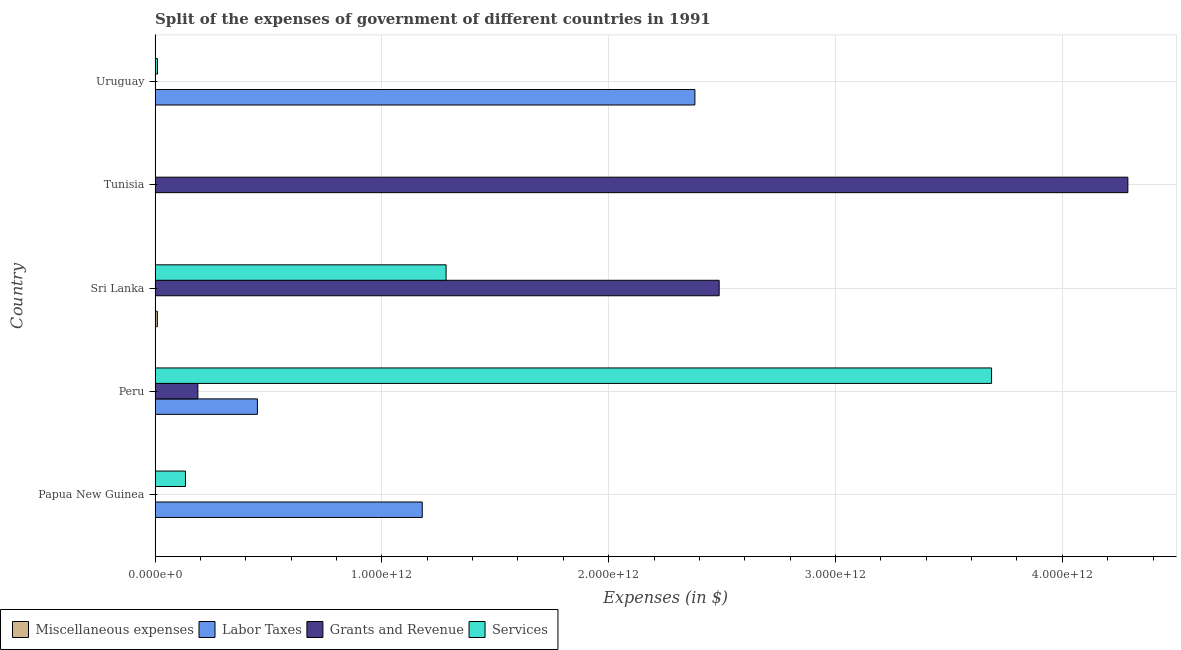Are the number of bars on each tick of the Y-axis equal?
Give a very brief answer. Yes. What is the label of the 3rd group of bars from the top?
Offer a terse response. Sri Lanka. In how many cases, is the number of bars for a given country not equal to the number of legend labels?
Your response must be concise. 0. What is the amount spent on grants and revenue in Uruguay?
Your answer should be very brief. 4.59e+08. Across all countries, what is the maximum amount spent on services?
Keep it short and to the point. 3.69e+12. In which country was the amount spent on grants and revenue maximum?
Keep it short and to the point. Tunisia. In which country was the amount spent on services minimum?
Keep it short and to the point. Tunisia. What is the total amount spent on miscellaneous expenses in the graph?
Provide a short and direct response. 1.04e+1. What is the difference between the amount spent on services in Papua New Guinea and that in Peru?
Keep it short and to the point. -3.55e+12. What is the difference between the amount spent on services in Sri Lanka and the amount spent on grants and revenue in Uruguay?
Give a very brief answer. 1.28e+12. What is the average amount spent on miscellaneous expenses per country?
Give a very brief answer. 2.07e+09. What is the difference between the amount spent on services and amount spent on labor taxes in Peru?
Give a very brief answer. 3.24e+12. In how many countries, is the amount spent on miscellaneous expenses greater than 2800000000000 $?
Ensure brevity in your answer.  0. What is the ratio of the amount spent on miscellaneous expenses in Peru to that in Sri Lanka?
Your answer should be very brief. 0. Is the difference between the amount spent on miscellaneous expenses in Sri Lanka and Tunisia greater than the difference between the amount spent on grants and revenue in Sri Lanka and Tunisia?
Your response must be concise. Yes. What is the difference between the highest and the second highest amount spent on miscellaneous expenses?
Make the answer very short. 9.67e+09. What is the difference between the highest and the lowest amount spent on labor taxes?
Offer a very short reply. 2.38e+12. In how many countries, is the amount spent on labor taxes greater than the average amount spent on labor taxes taken over all countries?
Offer a very short reply. 2. Is the sum of the amount spent on miscellaneous expenses in Papua New Guinea and Tunisia greater than the maximum amount spent on labor taxes across all countries?
Offer a very short reply. No. Is it the case that in every country, the sum of the amount spent on labor taxes and amount spent on grants and revenue is greater than the sum of amount spent on services and amount spent on miscellaneous expenses?
Provide a short and direct response. No. What does the 3rd bar from the top in Papua New Guinea represents?
Ensure brevity in your answer.  Labor Taxes. What does the 4th bar from the bottom in Sri Lanka represents?
Provide a succinct answer. Services. Is it the case that in every country, the sum of the amount spent on miscellaneous expenses and amount spent on labor taxes is greater than the amount spent on grants and revenue?
Provide a short and direct response. No. Are all the bars in the graph horizontal?
Provide a succinct answer. Yes. What is the difference between two consecutive major ticks on the X-axis?
Ensure brevity in your answer.  1.00e+12. How are the legend labels stacked?
Your answer should be very brief. Horizontal. What is the title of the graph?
Provide a succinct answer. Split of the expenses of government of different countries in 1991. Does "UNDP" appear as one of the legend labels in the graph?
Make the answer very short. No. What is the label or title of the X-axis?
Provide a short and direct response. Expenses (in $). What is the label or title of the Y-axis?
Make the answer very short. Country. What is the Expenses (in $) in Miscellaneous expenses in Papua New Guinea?
Your response must be concise. 5.01e+06. What is the Expenses (in $) in Labor Taxes in Papua New Guinea?
Keep it short and to the point. 1.18e+12. What is the Expenses (in $) of Grants and Revenue in Papua New Guinea?
Provide a short and direct response. 7.09e+08. What is the Expenses (in $) in Services in Papua New Guinea?
Offer a very short reply. 1.34e+11. What is the Expenses (in $) in Labor Taxes in Peru?
Offer a terse response. 4.51e+11. What is the Expenses (in $) in Grants and Revenue in Peru?
Give a very brief answer. 1.89e+11. What is the Expenses (in $) of Services in Peru?
Provide a succinct answer. 3.69e+12. What is the Expenses (in $) in Miscellaneous expenses in Sri Lanka?
Keep it short and to the point. 9.98e+09. What is the Expenses (in $) in Labor Taxes in Sri Lanka?
Provide a succinct answer. 7.18e+07. What is the Expenses (in $) in Grants and Revenue in Sri Lanka?
Provide a short and direct response. 2.49e+12. What is the Expenses (in $) of Services in Sri Lanka?
Ensure brevity in your answer.  1.28e+12. What is the Expenses (in $) of Miscellaneous expenses in Tunisia?
Your answer should be very brief. 3.12e+08. What is the Expenses (in $) in Labor Taxes in Tunisia?
Your response must be concise. 5.88e+08. What is the Expenses (in $) of Grants and Revenue in Tunisia?
Make the answer very short. 4.29e+12. What is the Expenses (in $) of Services in Tunisia?
Provide a short and direct response. 4.94e+07. What is the Expenses (in $) in Miscellaneous expenses in Uruguay?
Offer a very short reply. 5.50e+07. What is the Expenses (in $) in Labor Taxes in Uruguay?
Provide a succinct answer. 2.38e+12. What is the Expenses (in $) of Grants and Revenue in Uruguay?
Your answer should be very brief. 4.59e+08. What is the Expenses (in $) in Services in Uruguay?
Provide a succinct answer. 1.06e+1. Across all countries, what is the maximum Expenses (in $) of Miscellaneous expenses?
Offer a very short reply. 9.98e+09. Across all countries, what is the maximum Expenses (in $) in Labor Taxes?
Provide a short and direct response. 2.38e+12. Across all countries, what is the maximum Expenses (in $) in Grants and Revenue?
Give a very brief answer. 4.29e+12. Across all countries, what is the maximum Expenses (in $) in Services?
Ensure brevity in your answer.  3.69e+12. Across all countries, what is the minimum Expenses (in $) in Miscellaneous expenses?
Provide a short and direct response. 5.00e+06. Across all countries, what is the minimum Expenses (in $) of Labor Taxes?
Provide a short and direct response. 7.18e+07. Across all countries, what is the minimum Expenses (in $) in Grants and Revenue?
Make the answer very short. 4.59e+08. Across all countries, what is the minimum Expenses (in $) in Services?
Provide a succinct answer. 4.94e+07. What is the total Expenses (in $) in Miscellaneous expenses in the graph?
Your response must be concise. 1.04e+1. What is the total Expenses (in $) in Labor Taxes in the graph?
Offer a very short reply. 4.01e+12. What is the total Expenses (in $) of Grants and Revenue in the graph?
Make the answer very short. 6.97e+12. What is the total Expenses (in $) in Services in the graph?
Keep it short and to the point. 5.12e+12. What is the difference between the Expenses (in $) in Labor Taxes in Papua New Guinea and that in Peru?
Your answer should be very brief. 7.27e+11. What is the difference between the Expenses (in $) of Grants and Revenue in Papua New Guinea and that in Peru?
Your answer should be compact. -1.88e+11. What is the difference between the Expenses (in $) of Services in Papua New Guinea and that in Peru?
Provide a succinct answer. -3.55e+12. What is the difference between the Expenses (in $) of Miscellaneous expenses in Papua New Guinea and that in Sri Lanka?
Your answer should be very brief. -9.98e+09. What is the difference between the Expenses (in $) in Labor Taxes in Papua New Guinea and that in Sri Lanka?
Make the answer very short. 1.18e+12. What is the difference between the Expenses (in $) of Grants and Revenue in Papua New Guinea and that in Sri Lanka?
Give a very brief answer. -2.49e+12. What is the difference between the Expenses (in $) of Services in Papua New Guinea and that in Sri Lanka?
Your response must be concise. -1.15e+12. What is the difference between the Expenses (in $) in Miscellaneous expenses in Papua New Guinea and that in Tunisia?
Provide a succinct answer. -3.07e+08. What is the difference between the Expenses (in $) in Labor Taxes in Papua New Guinea and that in Tunisia?
Offer a very short reply. 1.18e+12. What is the difference between the Expenses (in $) in Grants and Revenue in Papua New Guinea and that in Tunisia?
Your answer should be compact. -4.29e+12. What is the difference between the Expenses (in $) of Services in Papua New Guinea and that in Tunisia?
Offer a terse response. 1.34e+11. What is the difference between the Expenses (in $) in Miscellaneous expenses in Papua New Guinea and that in Uruguay?
Ensure brevity in your answer.  -5.00e+07. What is the difference between the Expenses (in $) in Labor Taxes in Papua New Guinea and that in Uruguay?
Your answer should be compact. -1.20e+12. What is the difference between the Expenses (in $) of Grants and Revenue in Papua New Guinea and that in Uruguay?
Offer a terse response. 2.50e+08. What is the difference between the Expenses (in $) of Services in Papua New Guinea and that in Uruguay?
Your response must be concise. 1.23e+11. What is the difference between the Expenses (in $) of Miscellaneous expenses in Peru and that in Sri Lanka?
Provide a short and direct response. -9.98e+09. What is the difference between the Expenses (in $) in Labor Taxes in Peru and that in Sri Lanka?
Give a very brief answer. 4.51e+11. What is the difference between the Expenses (in $) of Grants and Revenue in Peru and that in Sri Lanka?
Your response must be concise. -2.30e+12. What is the difference between the Expenses (in $) in Services in Peru and that in Sri Lanka?
Make the answer very short. 2.40e+12. What is the difference between the Expenses (in $) of Miscellaneous expenses in Peru and that in Tunisia?
Provide a succinct answer. -3.07e+08. What is the difference between the Expenses (in $) in Labor Taxes in Peru and that in Tunisia?
Give a very brief answer. 4.51e+11. What is the difference between the Expenses (in $) of Grants and Revenue in Peru and that in Tunisia?
Your answer should be very brief. -4.10e+12. What is the difference between the Expenses (in $) of Services in Peru and that in Tunisia?
Offer a terse response. 3.69e+12. What is the difference between the Expenses (in $) of Miscellaneous expenses in Peru and that in Uruguay?
Offer a terse response. -5.00e+07. What is the difference between the Expenses (in $) of Labor Taxes in Peru and that in Uruguay?
Provide a short and direct response. -1.93e+12. What is the difference between the Expenses (in $) of Grants and Revenue in Peru and that in Uruguay?
Your answer should be compact. 1.88e+11. What is the difference between the Expenses (in $) in Services in Peru and that in Uruguay?
Ensure brevity in your answer.  3.68e+12. What is the difference between the Expenses (in $) in Miscellaneous expenses in Sri Lanka and that in Tunisia?
Keep it short and to the point. 9.67e+09. What is the difference between the Expenses (in $) of Labor Taxes in Sri Lanka and that in Tunisia?
Provide a succinct answer. -5.16e+08. What is the difference between the Expenses (in $) in Grants and Revenue in Sri Lanka and that in Tunisia?
Your response must be concise. -1.80e+12. What is the difference between the Expenses (in $) of Services in Sri Lanka and that in Tunisia?
Provide a short and direct response. 1.28e+12. What is the difference between the Expenses (in $) in Miscellaneous expenses in Sri Lanka and that in Uruguay?
Give a very brief answer. 9.93e+09. What is the difference between the Expenses (in $) in Labor Taxes in Sri Lanka and that in Uruguay?
Provide a short and direct response. -2.38e+12. What is the difference between the Expenses (in $) of Grants and Revenue in Sri Lanka and that in Uruguay?
Your answer should be very brief. 2.49e+12. What is the difference between the Expenses (in $) of Services in Sri Lanka and that in Uruguay?
Give a very brief answer. 1.27e+12. What is the difference between the Expenses (in $) in Miscellaneous expenses in Tunisia and that in Uruguay?
Your answer should be very brief. 2.57e+08. What is the difference between the Expenses (in $) of Labor Taxes in Tunisia and that in Uruguay?
Provide a succinct answer. -2.38e+12. What is the difference between the Expenses (in $) of Grants and Revenue in Tunisia and that in Uruguay?
Your answer should be compact. 4.29e+12. What is the difference between the Expenses (in $) in Services in Tunisia and that in Uruguay?
Provide a short and direct response. -1.05e+1. What is the difference between the Expenses (in $) of Miscellaneous expenses in Papua New Guinea and the Expenses (in $) of Labor Taxes in Peru?
Give a very brief answer. -4.51e+11. What is the difference between the Expenses (in $) in Miscellaneous expenses in Papua New Guinea and the Expenses (in $) in Grants and Revenue in Peru?
Your answer should be very brief. -1.89e+11. What is the difference between the Expenses (in $) in Miscellaneous expenses in Papua New Guinea and the Expenses (in $) in Services in Peru?
Provide a short and direct response. -3.69e+12. What is the difference between the Expenses (in $) of Labor Taxes in Papua New Guinea and the Expenses (in $) of Grants and Revenue in Peru?
Provide a succinct answer. 9.89e+11. What is the difference between the Expenses (in $) in Labor Taxes in Papua New Guinea and the Expenses (in $) in Services in Peru?
Offer a very short reply. -2.51e+12. What is the difference between the Expenses (in $) in Grants and Revenue in Papua New Guinea and the Expenses (in $) in Services in Peru?
Offer a very short reply. -3.69e+12. What is the difference between the Expenses (in $) in Miscellaneous expenses in Papua New Guinea and the Expenses (in $) in Labor Taxes in Sri Lanka?
Give a very brief answer. -6.68e+07. What is the difference between the Expenses (in $) of Miscellaneous expenses in Papua New Guinea and the Expenses (in $) of Grants and Revenue in Sri Lanka?
Offer a very short reply. -2.49e+12. What is the difference between the Expenses (in $) in Miscellaneous expenses in Papua New Guinea and the Expenses (in $) in Services in Sri Lanka?
Your answer should be compact. -1.28e+12. What is the difference between the Expenses (in $) of Labor Taxes in Papua New Guinea and the Expenses (in $) of Grants and Revenue in Sri Lanka?
Make the answer very short. -1.31e+12. What is the difference between the Expenses (in $) of Labor Taxes in Papua New Guinea and the Expenses (in $) of Services in Sri Lanka?
Make the answer very short. -1.05e+11. What is the difference between the Expenses (in $) of Grants and Revenue in Papua New Guinea and the Expenses (in $) of Services in Sri Lanka?
Your answer should be very brief. -1.28e+12. What is the difference between the Expenses (in $) of Miscellaneous expenses in Papua New Guinea and the Expenses (in $) of Labor Taxes in Tunisia?
Offer a terse response. -5.83e+08. What is the difference between the Expenses (in $) of Miscellaneous expenses in Papua New Guinea and the Expenses (in $) of Grants and Revenue in Tunisia?
Keep it short and to the point. -4.29e+12. What is the difference between the Expenses (in $) in Miscellaneous expenses in Papua New Guinea and the Expenses (in $) in Services in Tunisia?
Your response must be concise. -4.44e+07. What is the difference between the Expenses (in $) of Labor Taxes in Papua New Guinea and the Expenses (in $) of Grants and Revenue in Tunisia?
Your answer should be very brief. -3.11e+12. What is the difference between the Expenses (in $) in Labor Taxes in Papua New Guinea and the Expenses (in $) in Services in Tunisia?
Ensure brevity in your answer.  1.18e+12. What is the difference between the Expenses (in $) in Grants and Revenue in Papua New Guinea and the Expenses (in $) in Services in Tunisia?
Your answer should be very brief. 6.60e+08. What is the difference between the Expenses (in $) of Miscellaneous expenses in Papua New Guinea and the Expenses (in $) of Labor Taxes in Uruguay?
Offer a terse response. -2.38e+12. What is the difference between the Expenses (in $) of Miscellaneous expenses in Papua New Guinea and the Expenses (in $) of Grants and Revenue in Uruguay?
Your answer should be very brief. -4.54e+08. What is the difference between the Expenses (in $) of Miscellaneous expenses in Papua New Guinea and the Expenses (in $) of Services in Uruguay?
Keep it short and to the point. -1.06e+1. What is the difference between the Expenses (in $) of Labor Taxes in Papua New Guinea and the Expenses (in $) of Grants and Revenue in Uruguay?
Give a very brief answer. 1.18e+12. What is the difference between the Expenses (in $) in Labor Taxes in Papua New Guinea and the Expenses (in $) in Services in Uruguay?
Your answer should be very brief. 1.17e+12. What is the difference between the Expenses (in $) of Grants and Revenue in Papua New Guinea and the Expenses (in $) of Services in Uruguay?
Ensure brevity in your answer.  -9.85e+09. What is the difference between the Expenses (in $) in Miscellaneous expenses in Peru and the Expenses (in $) in Labor Taxes in Sri Lanka?
Offer a terse response. -6.68e+07. What is the difference between the Expenses (in $) in Miscellaneous expenses in Peru and the Expenses (in $) in Grants and Revenue in Sri Lanka?
Keep it short and to the point. -2.49e+12. What is the difference between the Expenses (in $) of Miscellaneous expenses in Peru and the Expenses (in $) of Services in Sri Lanka?
Give a very brief answer. -1.28e+12. What is the difference between the Expenses (in $) in Labor Taxes in Peru and the Expenses (in $) in Grants and Revenue in Sri Lanka?
Make the answer very short. -2.04e+12. What is the difference between the Expenses (in $) of Labor Taxes in Peru and the Expenses (in $) of Services in Sri Lanka?
Provide a short and direct response. -8.32e+11. What is the difference between the Expenses (in $) in Grants and Revenue in Peru and the Expenses (in $) in Services in Sri Lanka?
Provide a short and direct response. -1.09e+12. What is the difference between the Expenses (in $) in Miscellaneous expenses in Peru and the Expenses (in $) in Labor Taxes in Tunisia?
Offer a terse response. -5.83e+08. What is the difference between the Expenses (in $) in Miscellaneous expenses in Peru and the Expenses (in $) in Grants and Revenue in Tunisia?
Provide a short and direct response. -4.29e+12. What is the difference between the Expenses (in $) in Miscellaneous expenses in Peru and the Expenses (in $) in Services in Tunisia?
Give a very brief answer. -4.44e+07. What is the difference between the Expenses (in $) in Labor Taxes in Peru and the Expenses (in $) in Grants and Revenue in Tunisia?
Your answer should be compact. -3.84e+12. What is the difference between the Expenses (in $) of Labor Taxes in Peru and the Expenses (in $) of Services in Tunisia?
Your answer should be compact. 4.51e+11. What is the difference between the Expenses (in $) of Grants and Revenue in Peru and the Expenses (in $) of Services in Tunisia?
Offer a very short reply. 1.89e+11. What is the difference between the Expenses (in $) of Miscellaneous expenses in Peru and the Expenses (in $) of Labor Taxes in Uruguay?
Give a very brief answer. -2.38e+12. What is the difference between the Expenses (in $) of Miscellaneous expenses in Peru and the Expenses (in $) of Grants and Revenue in Uruguay?
Make the answer very short. -4.54e+08. What is the difference between the Expenses (in $) in Miscellaneous expenses in Peru and the Expenses (in $) in Services in Uruguay?
Make the answer very short. -1.06e+1. What is the difference between the Expenses (in $) of Labor Taxes in Peru and the Expenses (in $) of Grants and Revenue in Uruguay?
Make the answer very short. 4.51e+11. What is the difference between the Expenses (in $) of Labor Taxes in Peru and the Expenses (in $) of Services in Uruguay?
Ensure brevity in your answer.  4.41e+11. What is the difference between the Expenses (in $) in Grants and Revenue in Peru and the Expenses (in $) in Services in Uruguay?
Your answer should be compact. 1.78e+11. What is the difference between the Expenses (in $) of Miscellaneous expenses in Sri Lanka and the Expenses (in $) of Labor Taxes in Tunisia?
Give a very brief answer. 9.39e+09. What is the difference between the Expenses (in $) of Miscellaneous expenses in Sri Lanka and the Expenses (in $) of Grants and Revenue in Tunisia?
Your answer should be compact. -4.28e+12. What is the difference between the Expenses (in $) of Miscellaneous expenses in Sri Lanka and the Expenses (in $) of Services in Tunisia?
Give a very brief answer. 9.93e+09. What is the difference between the Expenses (in $) of Labor Taxes in Sri Lanka and the Expenses (in $) of Grants and Revenue in Tunisia?
Your answer should be compact. -4.29e+12. What is the difference between the Expenses (in $) of Labor Taxes in Sri Lanka and the Expenses (in $) of Services in Tunisia?
Make the answer very short. 2.24e+07. What is the difference between the Expenses (in $) in Grants and Revenue in Sri Lanka and the Expenses (in $) in Services in Tunisia?
Your answer should be compact. 2.49e+12. What is the difference between the Expenses (in $) of Miscellaneous expenses in Sri Lanka and the Expenses (in $) of Labor Taxes in Uruguay?
Offer a terse response. -2.37e+12. What is the difference between the Expenses (in $) in Miscellaneous expenses in Sri Lanka and the Expenses (in $) in Grants and Revenue in Uruguay?
Your answer should be compact. 9.52e+09. What is the difference between the Expenses (in $) in Miscellaneous expenses in Sri Lanka and the Expenses (in $) in Services in Uruguay?
Keep it short and to the point. -5.76e+08. What is the difference between the Expenses (in $) of Labor Taxes in Sri Lanka and the Expenses (in $) of Grants and Revenue in Uruguay?
Provide a succinct answer. -3.88e+08. What is the difference between the Expenses (in $) in Labor Taxes in Sri Lanka and the Expenses (in $) in Services in Uruguay?
Provide a succinct answer. -1.05e+1. What is the difference between the Expenses (in $) in Grants and Revenue in Sri Lanka and the Expenses (in $) in Services in Uruguay?
Give a very brief answer. 2.48e+12. What is the difference between the Expenses (in $) in Miscellaneous expenses in Tunisia and the Expenses (in $) in Labor Taxes in Uruguay?
Offer a very short reply. -2.38e+12. What is the difference between the Expenses (in $) of Miscellaneous expenses in Tunisia and the Expenses (in $) of Grants and Revenue in Uruguay?
Keep it short and to the point. -1.48e+08. What is the difference between the Expenses (in $) in Miscellaneous expenses in Tunisia and the Expenses (in $) in Services in Uruguay?
Your answer should be very brief. -1.02e+1. What is the difference between the Expenses (in $) in Labor Taxes in Tunisia and the Expenses (in $) in Grants and Revenue in Uruguay?
Make the answer very short. 1.29e+08. What is the difference between the Expenses (in $) of Labor Taxes in Tunisia and the Expenses (in $) of Services in Uruguay?
Offer a very short reply. -9.97e+09. What is the difference between the Expenses (in $) of Grants and Revenue in Tunisia and the Expenses (in $) of Services in Uruguay?
Ensure brevity in your answer.  4.28e+12. What is the average Expenses (in $) in Miscellaneous expenses per country?
Keep it short and to the point. 2.07e+09. What is the average Expenses (in $) of Labor Taxes per country?
Your response must be concise. 8.02e+11. What is the average Expenses (in $) in Grants and Revenue per country?
Give a very brief answer. 1.39e+12. What is the average Expenses (in $) in Services per country?
Provide a succinct answer. 1.02e+12. What is the difference between the Expenses (in $) in Miscellaneous expenses and Expenses (in $) in Labor Taxes in Papua New Guinea?
Your answer should be very brief. -1.18e+12. What is the difference between the Expenses (in $) in Miscellaneous expenses and Expenses (in $) in Grants and Revenue in Papua New Guinea?
Offer a very short reply. -7.04e+08. What is the difference between the Expenses (in $) in Miscellaneous expenses and Expenses (in $) in Services in Papua New Guinea?
Give a very brief answer. -1.34e+11. What is the difference between the Expenses (in $) of Labor Taxes and Expenses (in $) of Grants and Revenue in Papua New Guinea?
Offer a very short reply. 1.18e+12. What is the difference between the Expenses (in $) in Labor Taxes and Expenses (in $) in Services in Papua New Guinea?
Your response must be concise. 1.04e+12. What is the difference between the Expenses (in $) of Grants and Revenue and Expenses (in $) of Services in Papua New Guinea?
Your response must be concise. -1.33e+11. What is the difference between the Expenses (in $) in Miscellaneous expenses and Expenses (in $) in Labor Taxes in Peru?
Provide a short and direct response. -4.51e+11. What is the difference between the Expenses (in $) in Miscellaneous expenses and Expenses (in $) in Grants and Revenue in Peru?
Keep it short and to the point. -1.89e+11. What is the difference between the Expenses (in $) of Miscellaneous expenses and Expenses (in $) of Services in Peru?
Provide a succinct answer. -3.69e+12. What is the difference between the Expenses (in $) of Labor Taxes and Expenses (in $) of Grants and Revenue in Peru?
Offer a very short reply. 2.63e+11. What is the difference between the Expenses (in $) of Labor Taxes and Expenses (in $) of Services in Peru?
Provide a succinct answer. -3.24e+12. What is the difference between the Expenses (in $) in Grants and Revenue and Expenses (in $) in Services in Peru?
Your answer should be very brief. -3.50e+12. What is the difference between the Expenses (in $) in Miscellaneous expenses and Expenses (in $) in Labor Taxes in Sri Lanka?
Provide a succinct answer. 9.91e+09. What is the difference between the Expenses (in $) of Miscellaneous expenses and Expenses (in $) of Grants and Revenue in Sri Lanka?
Offer a very short reply. -2.48e+12. What is the difference between the Expenses (in $) of Miscellaneous expenses and Expenses (in $) of Services in Sri Lanka?
Your answer should be compact. -1.27e+12. What is the difference between the Expenses (in $) of Labor Taxes and Expenses (in $) of Grants and Revenue in Sri Lanka?
Your response must be concise. -2.49e+12. What is the difference between the Expenses (in $) in Labor Taxes and Expenses (in $) in Services in Sri Lanka?
Keep it short and to the point. -1.28e+12. What is the difference between the Expenses (in $) in Grants and Revenue and Expenses (in $) in Services in Sri Lanka?
Your response must be concise. 1.20e+12. What is the difference between the Expenses (in $) of Miscellaneous expenses and Expenses (in $) of Labor Taxes in Tunisia?
Offer a very short reply. -2.76e+08. What is the difference between the Expenses (in $) of Miscellaneous expenses and Expenses (in $) of Grants and Revenue in Tunisia?
Offer a terse response. -4.29e+12. What is the difference between the Expenses (in $) in Miscellaneous expenses and Expenses (in $) in Services in Tunisia?
Provide a succinct answer. 2.62e+08. What is the difference between the Expenses (in $) in Labor Taxes and Expenses (in $) in Grants and Revenue in Tunisia?
Make the answer very short. -4.29e+12. What is the difference between the Expenses (in $) in Labor Taxes and Expenses (in $) in Services in Tunisia?
Make the answer very short. 5.39e+08. What is the difference between the Expenses (in $) of Grants and Revenue and Expenses (in $) of Services in Tunisia?
Your response must be concise. 4.29e+12. What is the difference between the Expenses (in $) in Miscellaneous expenses and Expenses (in $) in Labor Taxes in Uruguay?
Your answer should be compact. -2.38e+12. What is the difference between the Expenses (in $) of Miscellaneous expenses and Expenses (in $) of Grants and Revenue in Uruguay?
Your response must be concise. -4.04e+08. What is the difference between the Expenses (in $) of Miscellaneous expenses and Expenses (in $) of Services in Uruguay?
Provide a short and direct response. -1.05e+1. What is the difference between the Expenses (in $) in Labor Taxes and Expenses (in $) in Grants and Revenue in Uruguay?
Give a very brief answer. 2.38e+12. What is the difference between the Expenses (in $) of Labor Taxes and Expenses (in $) of Services in Uruguay?
Provide a succinct answer. 2.37e+12. What is the difference between the Expenses (in $) in Grants and Revenue and Expenses (in $) in Services in Uruguay?
Your answer should be compact. -1.01e+1. What is the ratio of the Expenses (in $) in Miscellaneous expenses in Papua New Guinea to that in Peru?
Offer a terse response. 1. What is the ratio of the Expenses (in $) of Labor Taxes in Papua New Guinea to that in Peru?
Make the answer very short. 2.61. What is the ratio of the Expenses (in $) of Grants and Revenue in Papua New Guinea to that in Peru?
Make the answer very short. 0. What is the ratio of the Expenses (in $) in Services in Papua New Guinea to that in Peru?
Provide a short and direct response. 0.04. What is the ratio of the Expenses (in $) in Labor Taxes in Papua New Guinea to that in Sri Lanka?
Provide a succinct answer. 1.64e+04. What is the ratio of the Expenses (in $) in Services in Papua New Guinea to that in Sri Lanka?
Your answer should be compact. 0.1. What is the ratio of the Expenses (in $) of Miscellaneous expenses in Papua New Guinea to that in Tunisia?
Provide a short and direct response. 0.02. What is the ratio of the Expenses (in $) in Labor Taxes in Papua New Guinea to that in Tunisia?
Make the answer very short. 2003.4. What is the ratio of the Expenses (in $) of Services in Papua New Guinea to that in Tunisia?
Offer a terse response. 2711.39. What is the ratio of the Expenses (in $) in Miscellaneous expenses in Papua New Guinea to that in Uruguay?
Keep it short and to the point. 0.09. What is the ratio of the Expenses (in $) in Labor Taxes in Papua New Guinea to that in Uruguay?
Make the answer very short. 0.49. What is the ratio of the Expenses (in $) of Grants and Revenue in Papua New Guinea to that in Uruguay?
Your answer should be very brief. 1.54. What is the ratio of the Expenses (in $) in Services in Papua New Guinea to that in Uruguay?
Offer a very short reply. 12.69. What is the ratio of the Expenses (in $) of Labor Taxes in Peru to that in Sri Lanka?
Offer a terse response. 6279.75. What is the ratio of the Expenses (in $) of Grants and Revenue in Peru to that in Sri Lanka?
Make the answer very short. 0.08. What is the ratio of the Expenses (in $) of Services in Peru to that in Sri Lanka?
Provide a succinct answer. 2.87. What is the ratio of the Expenses (in $) of Miscellaneous expenses in Peru to that in Tunisia?
Your answer should be compact. 0.02. What is the ratio of the Expenses (in $) of Labor Taxes in Peru to that in Tunisia?
Ensure brevity in your answer.  767.35. What is the ratio of the Expenses (in $) of Grants and Revenue in Peru to that in Tunisia?
Give a very brief answer. 0.04. What is the ratio of the Expenses (in $) of Services in Peru to that in Tunisia?
Provide a succinct answer. 7.46e+04. What is the ratio of the Expenses (in $) of Miscellaneous expenses in Peru to that in Uruguay?
Make the answer very short. 0.09. What is the ratio of the Expenses (in $) in Labor Taxes in Peru to that in Uruguay?
Offer a very short reply. 0.19. What is the ratio of the Expenses (in $) of Grants and Revenue in Peru to that in Uruguay?
Keep it short and to the point. 410.66. What is the ratio of the Expenses (in $) in Services in Peru to that in Uruguay?
Offer a very short reply. 349.31. What is the ratio of the Expenses (in $) of Miscellaneous expenses in Sri Lanka to that in Tunisia?
Keep it short and to the point. 32.03. What is the ratio of the Expenses (in $) in Labor Taxes in Sri Lanka to that in Tunisia?
Keep it short and to the point. 0.12. What is the ratio of the Expenses (in $) in Grants and Revenue in Sri Lanka to that in Tunisia?
Give a very brief answer. 0.58. What is the ratio of the Expenses (in $) of Services in Sri Lanka to that in Tunisia?
Your answer should be very brief. 2.60e+04. What is the ratio of the Expenses (in $) of Miscellaneous expenses in Sri Lanka to that in Uruguay?
Make the answer very short. 181.49. What is the ratio of the Expenses (in $) in Labor Taxes in Sri Lanka to that in Uruguay?
Provide a succinct answer. 0. What is the ratio of the Expenses (in $) of Grants and Revenue in Sri Lanka to that in Uruguay?
Keep it short and to the point. 5412.88. What is the ratio of the Expenses (in $) in Services in Sri Lanka to that in Uruguay?
Your answer should be very brief. 121.52. What is the ratio of the Expenses (in $) in Miscellaneous expenses in Tunisia to that in Uruguay?
Offer a very short reply. 5.67. What is the ratio of the Expenses (in $) of Grants and Revenue in Tunisia to that in Uruguay?
Offer a very short reply. 9334.44. What is the ratio of the Expenses (in $) of Services in Tunisia to that in Uruguay?
Ensure brevity in your answer.  0. What is the difference between the highest and the second highest Expenses (in $) of Miscellaneous expenses?
Make the answer very short. 9.67e+09. What is the difference between the highest and the second highest Expenses (in $) in Labor Taxes?
Your response must be concise. 1.20e+12. What is the difference between the highest and the second highest Expenses (in $) in Grants and Revenue?
Keep it short and to the point. 1.80e+12. What is the difference between the highest and the second highest Expenses (in $) in Services?
Offer a very short reply. 2.40e+12. What is the difference between the highest and the lowest Expenses (in $) in Miscellaneous expenses?
Your response must be concise. 9.98e+09. What is the difference between the highest and the lowest Expenses (in $) of Labor Taxes?
Offer a very short reply. 2.38e+12. What is the difference between the highest and the lowest Expenses (in $) in Grants and Revenue?
Offer a terse response. 4.29e+12. What is the difference between the highest and the lowest Expenses (in $) of Services?
Ensure brevity in your answer.  3.69e+12. 